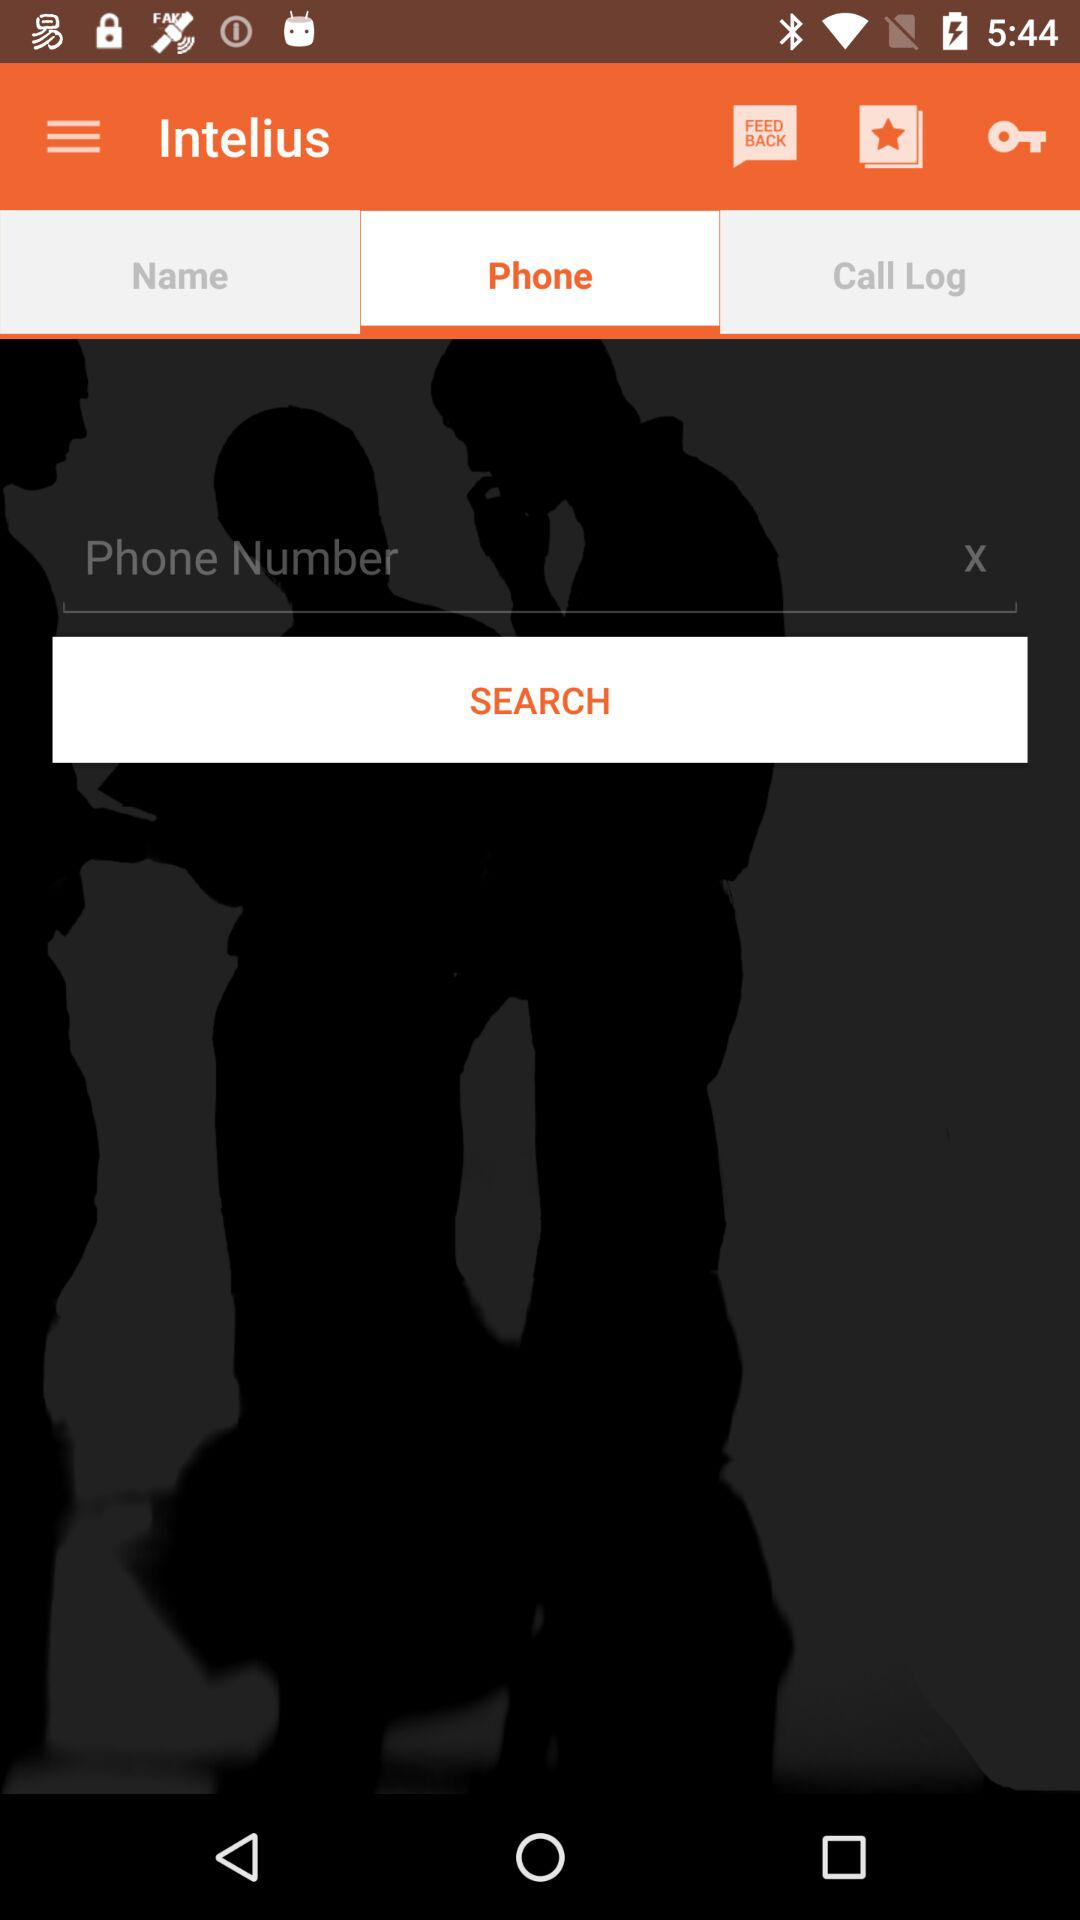On which tab am I now? You are on "Phone" tab. 